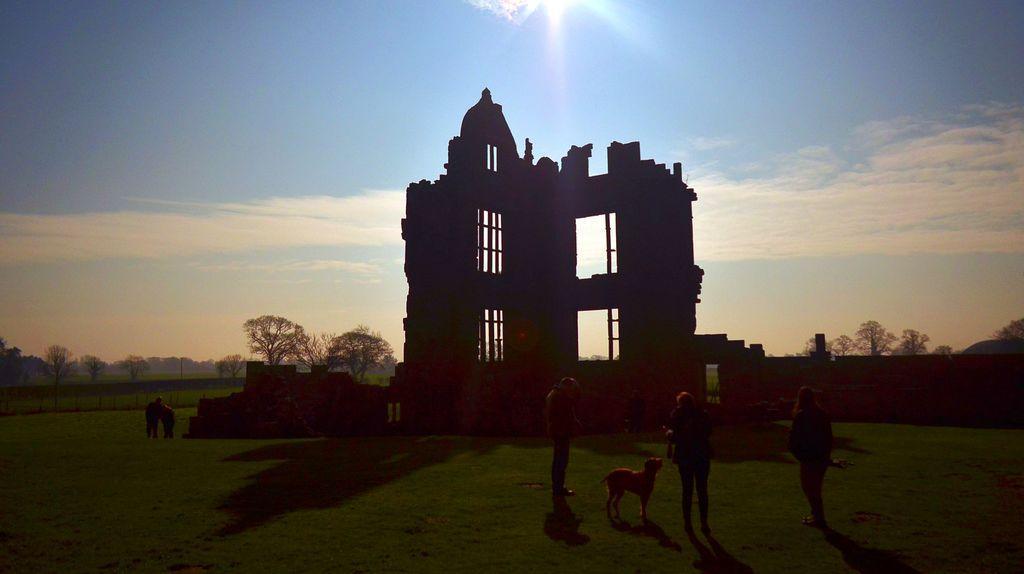In one or two sentences, can you explain what this image depicts? In this image there is a building with fencing wall on both the sides. There are few persons standing on the grass and there is also a dog in this image. In the background there are trees. At the top there is a sky with clouds. Sun is also visible. 